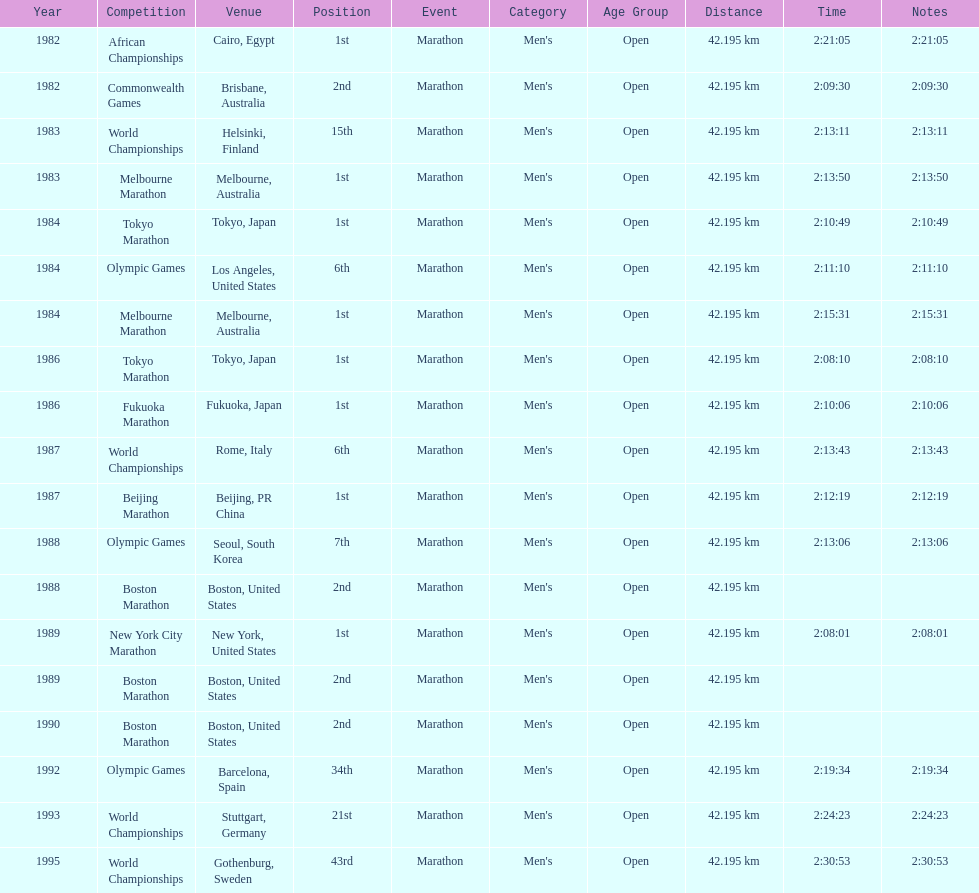What are the total number of times the position of 1st place was earned? 8. 